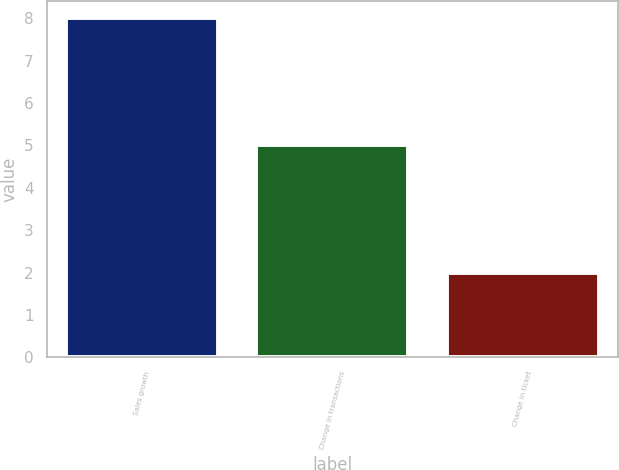Convert chart to OTSL. <chart><loc_0><loc_0><loc_500><loc_500><bar_chart><fcel>Sales growth<fcel>Change in transactions<fcel>Change in ticket<nl><fcel>8<fcel>5<fcel>2<nl></chart> 